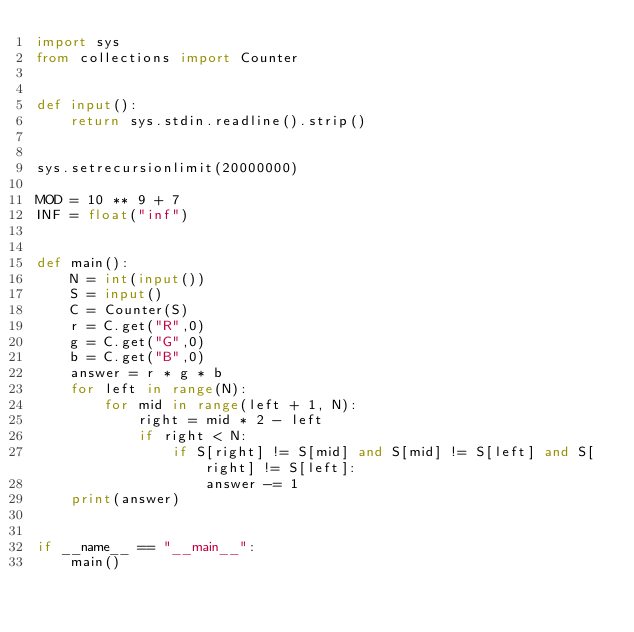<code> <loc_0><loc_0><loc_500><loc_500><_Python_>import sys
from collections import Counter


def input():
    return sys.stdin.readline().strip()


sys.setrecursionlimit(20000000)

MOD = 10 ** 9 + 7
INF = float("inf")


def main():
    N = int(input())
    S = input()
    C = Counter(S)
    r = C.get("R",0)
    g = C.get("G",0)
    b = C.get("B",0)
    answer = r * g * b
    for left in range(N):
        for mid in range(left + 1, N):
            right = mid * 2 - left
            if right < N:
                if S[right] != S[mid] and S[mid] != S[left] and S[right] != S[left]:
                    answer -= 1
    print(answer)


if __name__ == "__main__":
    main()
</code> 